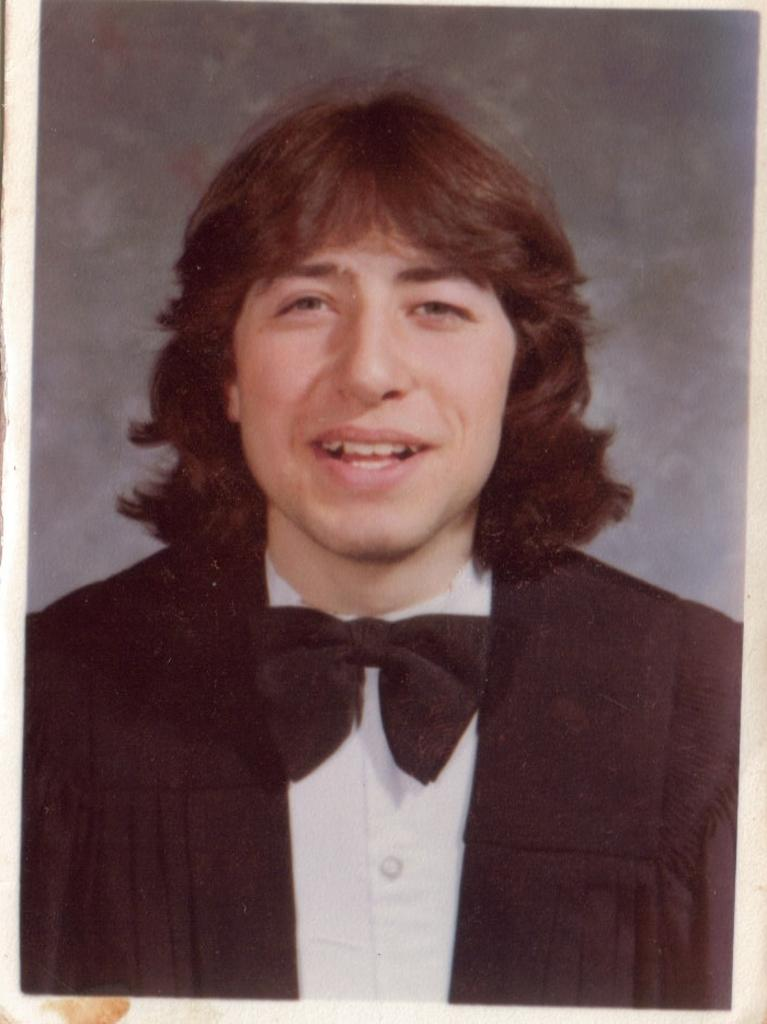What is the main subject of the image? There is a photo of one person in the image. What color is the hen in the image? There is no hen present in the image; it only features a photo of one person. 